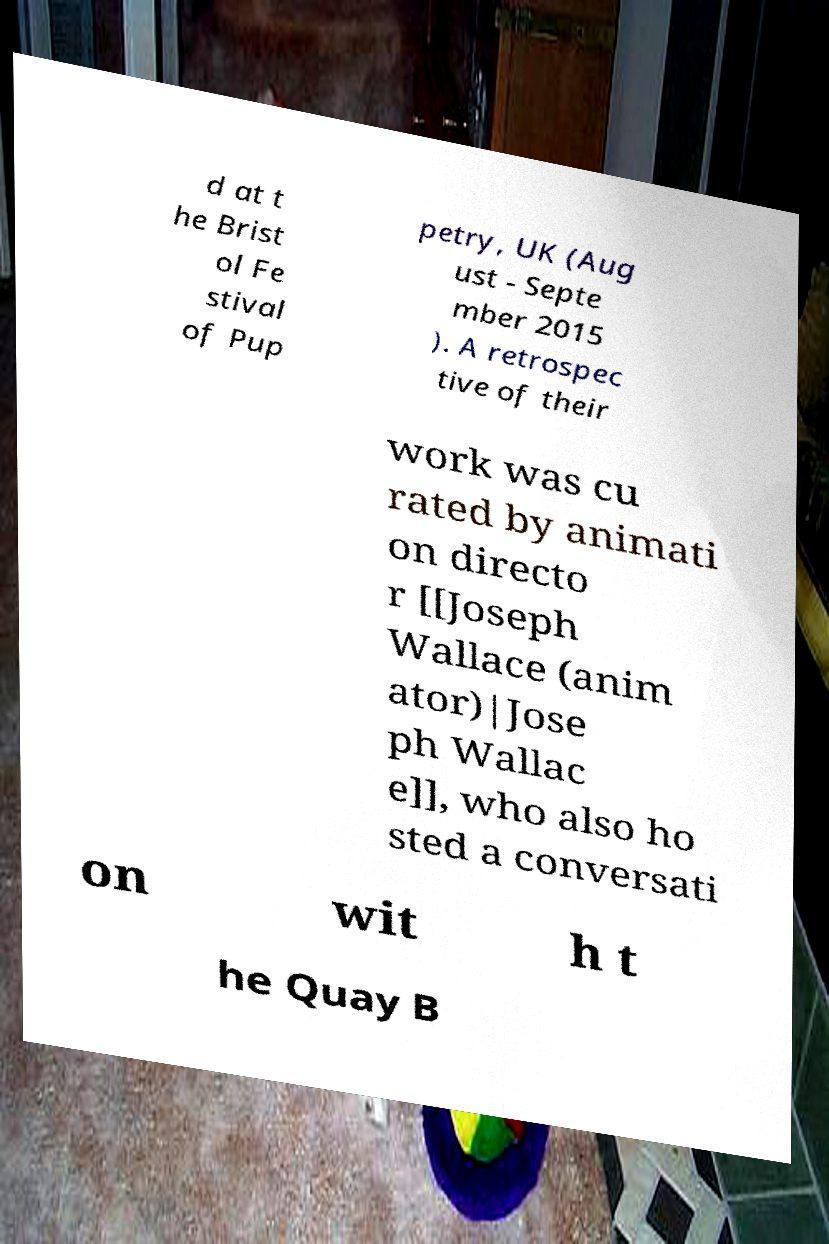What messages or text are displayed in this image? I need them in a readable, typed format. d at t he Brist ol Fe stival of Pup petry, UK (Aug ust - Septe mber 2015 ). A retrospec tive of their work was cu rated by animati on directo r [[Joseph Wallace (anim ator)|Jose ph Wallac e]], who also ho sted a conversati on wit h t he Quay B 